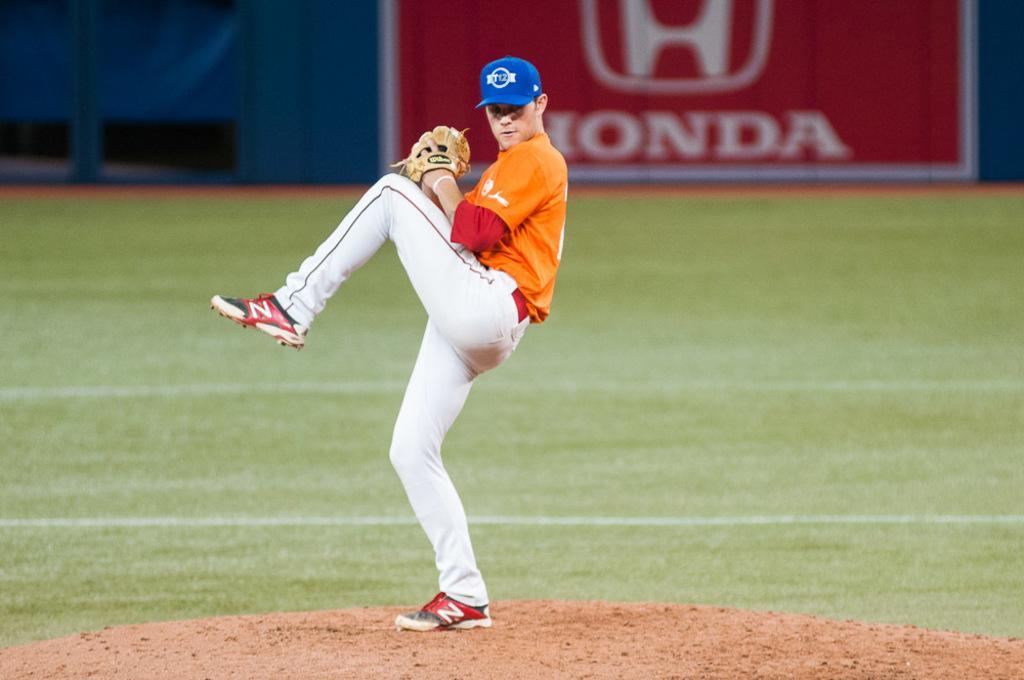Can you describe this image briefly? In this image I can see the person standing on the ground. The person is wearing the white, red and orange color dress. And the person with the blue color cap and the gloves. In the back there is a red color board and I can see the name Honda is written on it. I can also see the blue color wall in the back. 